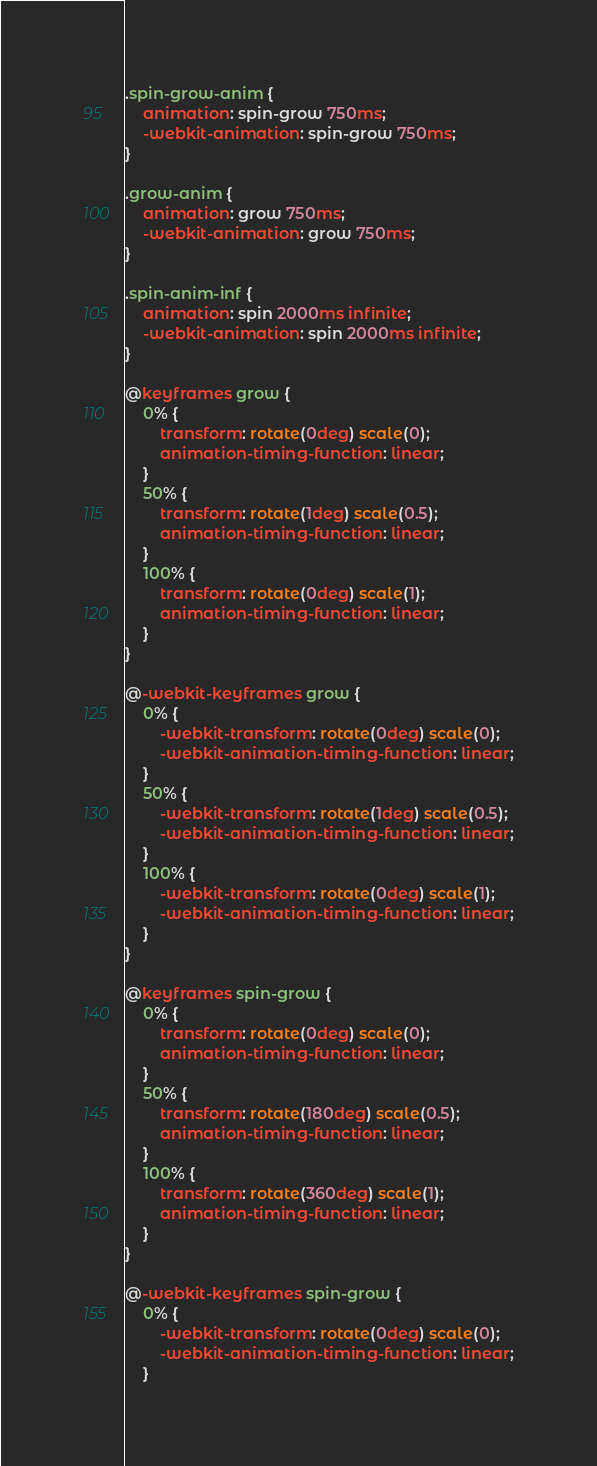Convert code to text. <code><loc_0><loc_0><loc_500><loc_500><_CSS_>.spin-grow-anim {
    animation: spin-grow 750ms;
    -webkit-animation: spin-grow 750ms;
}

.grow-anim {
    animation: grow 750ms;
    -webkit-animation: grow 750ms;
}

.spin-anim-inf {
    animation: spin 2000ms infinite;
    -webkit-animation: spin 2000ms infinite;
}

@keyframes grow {
    0% {
        transform: rotate(0deg) scale(0);
        animation-timing-function: linear;
    }
    50% {
        transform: rotate(1deg) scale(0.5);
        animation-timing-function: linear;
    }
    100% {
        transform: rotate(0deg) scale(1);
        animation-timing-function: linear;
    }
}

@-webkit-keyframes grow {
    0% {
        -webkit-transform: rotate(0deg) scale(0);
        -webkit-animation-timing-function: linear;
    }
    50% {
        -webkit-transform: rotate(1deg) scale(0.5);
        -webkit-animation-timing-function: linear;
    }
    100% {
        -webkit-transform: rotate(0deg) scale(1);
        -webkit-animation-timing-function: linear;
    }
}

@keyframes spin-grow {
    0% {
        transform: rotate(0deg) scale(0);
        animation-timing-function: linear;
    }
    50% {
        transform: rotate(180deg) scale(0.5);
        animation-timing-function: linear;
    }
    100% {
        transform: rotate(360deg) scale(1);
        animation-timing-function: linear;
    }
}

@-webkit-keyframes spin-grow {
    0% {
        -webkit-transform: rotate(0deg) scale(0);
        -webkit-animation-timing-function: linear;
    }</code> 